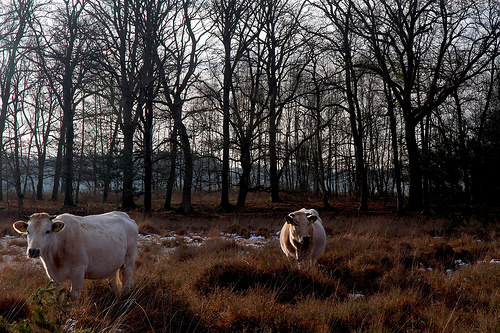<image>
Is the cow on the grass? Yes. Looking at the image, I can see the cow is positioned on top of the grass, with the grass providing support. Is there a tree to the left of the cow? Yes. From this viewpoint, the tree is positioned to the left side relative to the cow. 